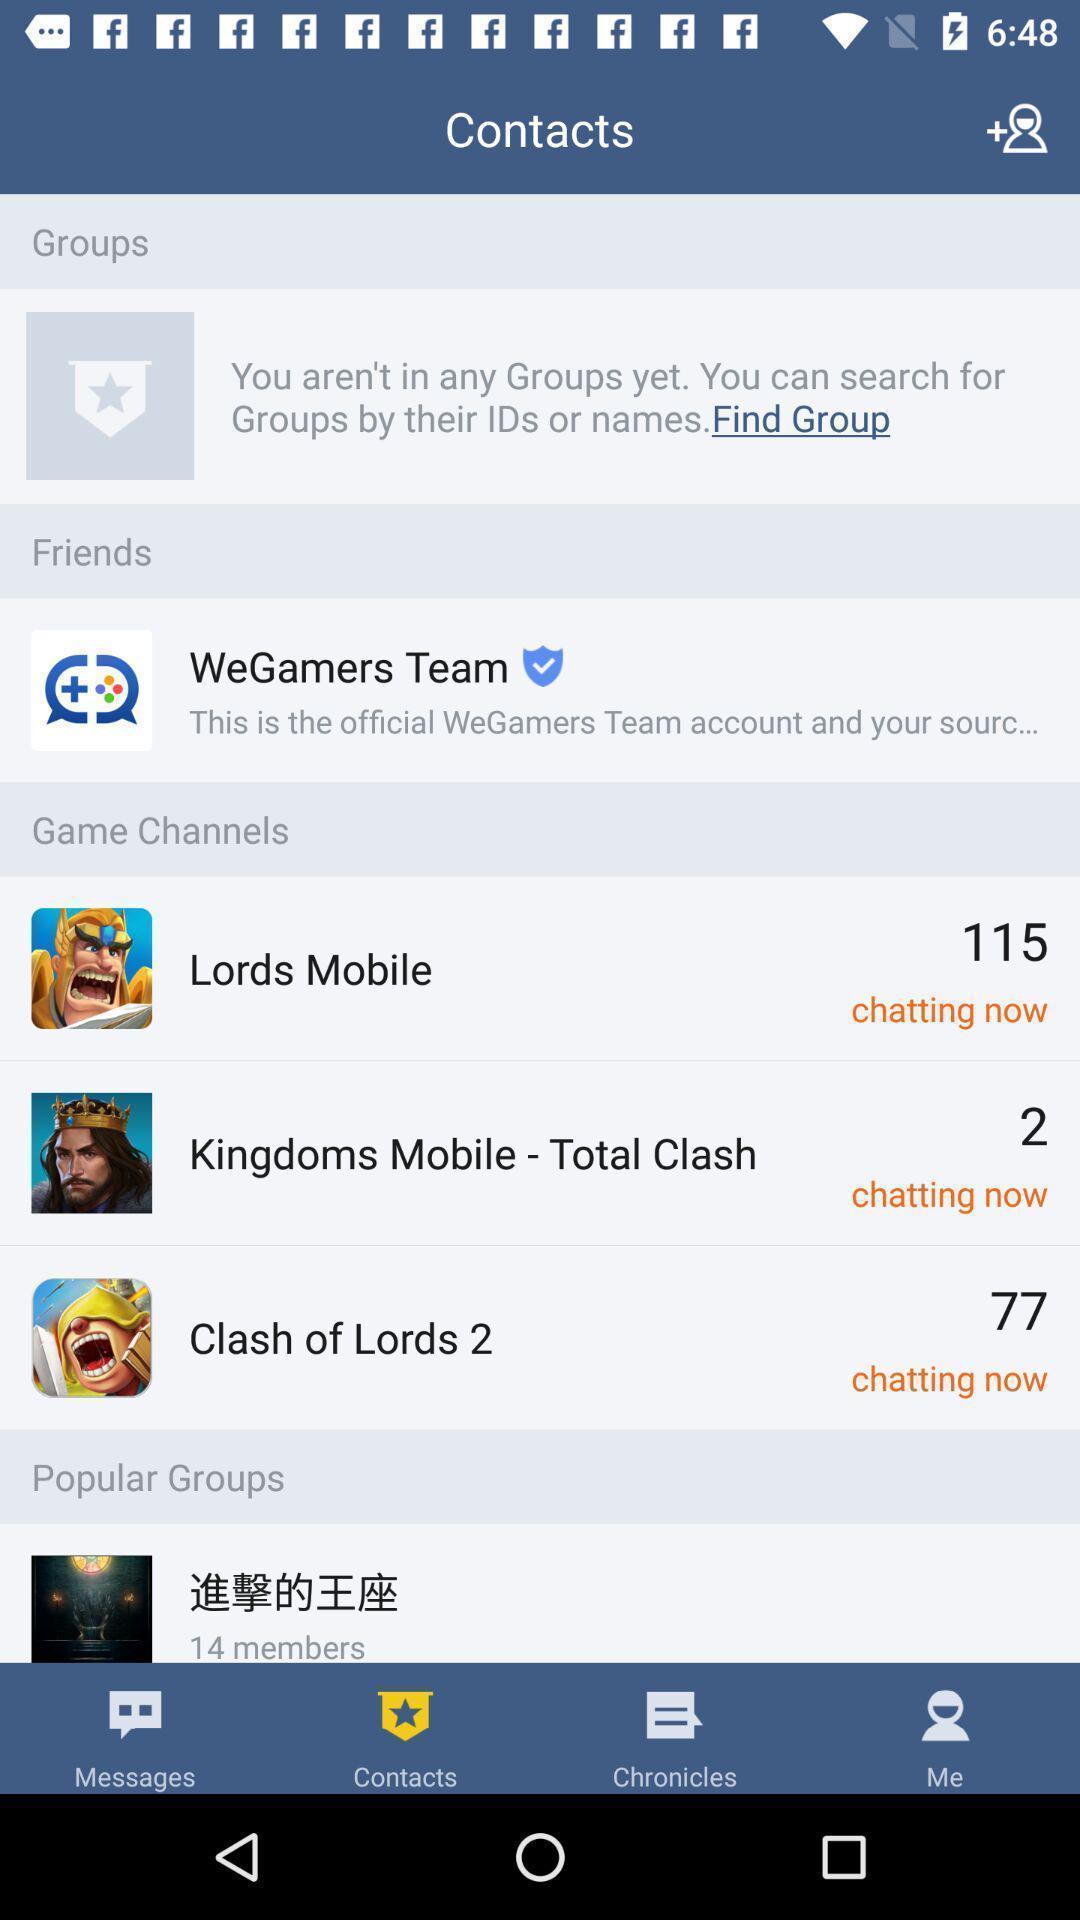Summarize the information in this screenshot. Screen displaying channels of different games. 